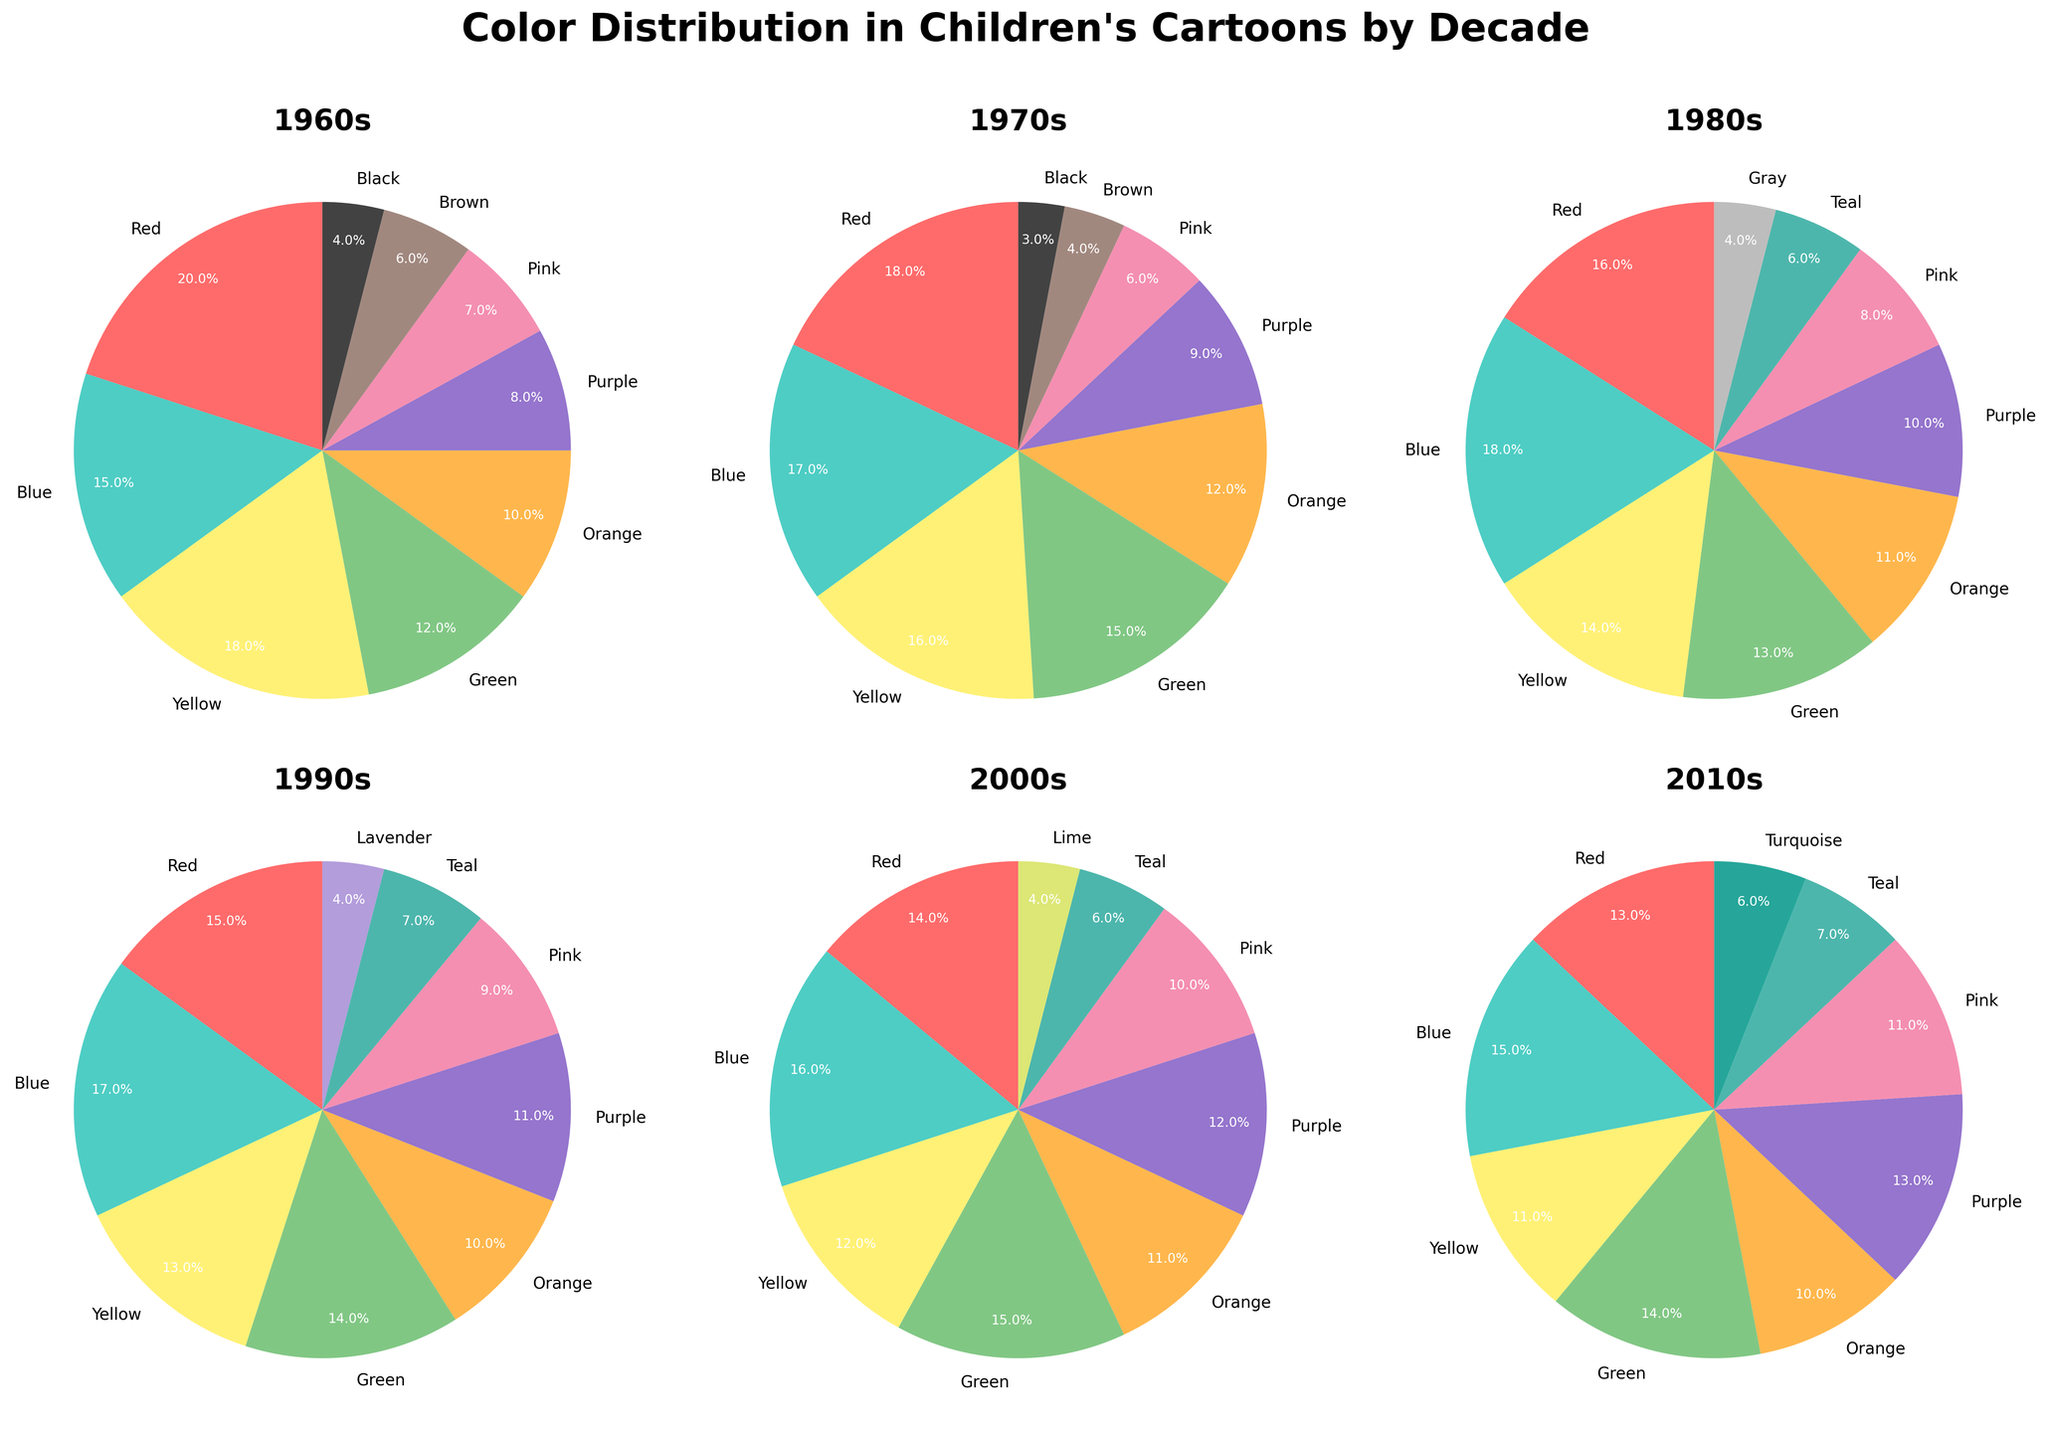What is the total percentage of shades of blue (Blue, Teal, Turquoise) used in the 2010s? First, identify the percentages for Blue (15), Teal (7), and Turquoise (6) in the 2010s. Then, sum these values: 15 + 7 + 6 = 28.
Answer: 28% How does the percentage of Red change from the 1960s to the 2010s? Red is 20% in the 1960s and decreases to 13% in the 2010s. The difference is 20 - 13 = 7.
Answer: Decreases by 7% Which decade has the highest percentage of Purple? The 2010s have 13% Purple, which is the highest compared to other decades (1960s: 8%, 1970s: 9%, 1980s: 10%, 1990s: 11%, 2000s: 12%).
Answer: 2010s In the 1980s, which color has the highest percentage, and what is it? Identify the highest percentage among all colors in the 1980s. The highest is Blue with 18%.
Answer: Blue, 18% What are the two least used colors in the 1970s and their percentages? The two least used colors in the 1970s are Black (3%) and Brown (4%).
Answer: Black (3%), Brown (4%) Compare the percentage of Yellow in the 1960s and 2000s. Which decade used more Yellow and by how much? Yellow is 18% in the 1960s and 12% in the 2000s. The 1960s used more Yellow by 18 - 12 = 6%.
Answer: 1960s, 6% What is the average percentage of Blue across all the decades? First, sum up the Blue percentages for each decade: 15 + 17 + 18 + 17 + 16 + 15 = 98. Then divide by the number of decades: 98 / 6 = 16.33.
Answer: 16.33% Is the percentage of Green higher in the 1980s or the 1990s, and by how much? Green is 13% in the 1980s and 14% in the 1990s. The percentage of Green is higher in the 1990s by 14 - 13 = 1%.
Answer: 1990s, 1% What color consistently appears in every decade and what is the highest percentage it reaches? Identify a color that appears in each decade. Blue is present every decade, with its highest percentage being 18% in the 1980s.
Answer: Blue, 18% 